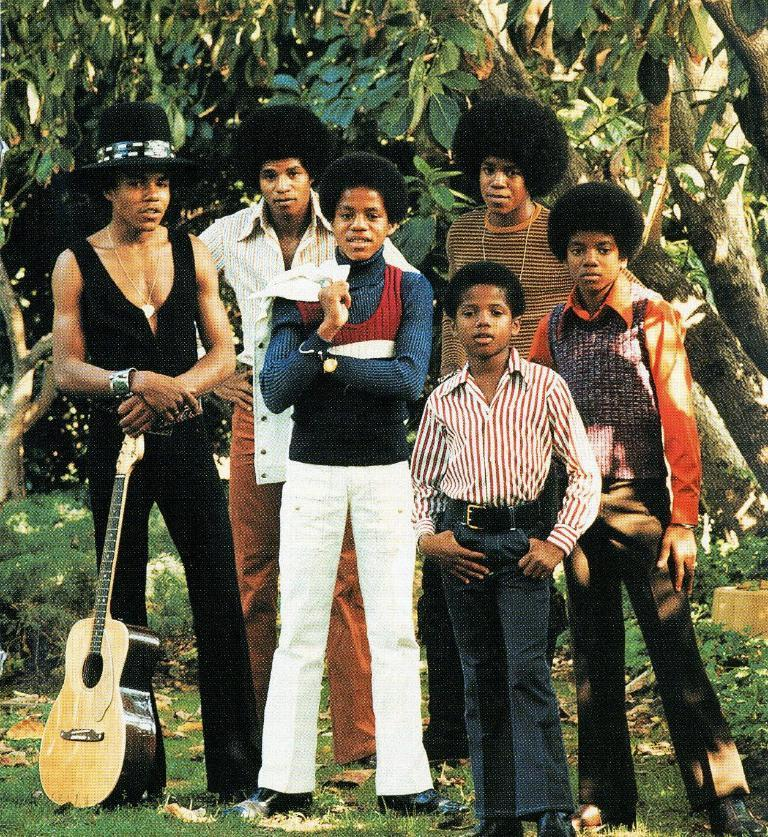What are the people in the image doing? There is a group of people standing in the image. Can you identify any specific object or item that one person is holding? Yes, one person is holding a guitar. What can be seen in the background of the image? There are trees visible in the background. What part of the trees can be seen in the image? The trunks of the trees are visible. What type of texture can be seen on the apples in the image? There are no apples present in the image, so it is not possible to determine the texture of any apples. 